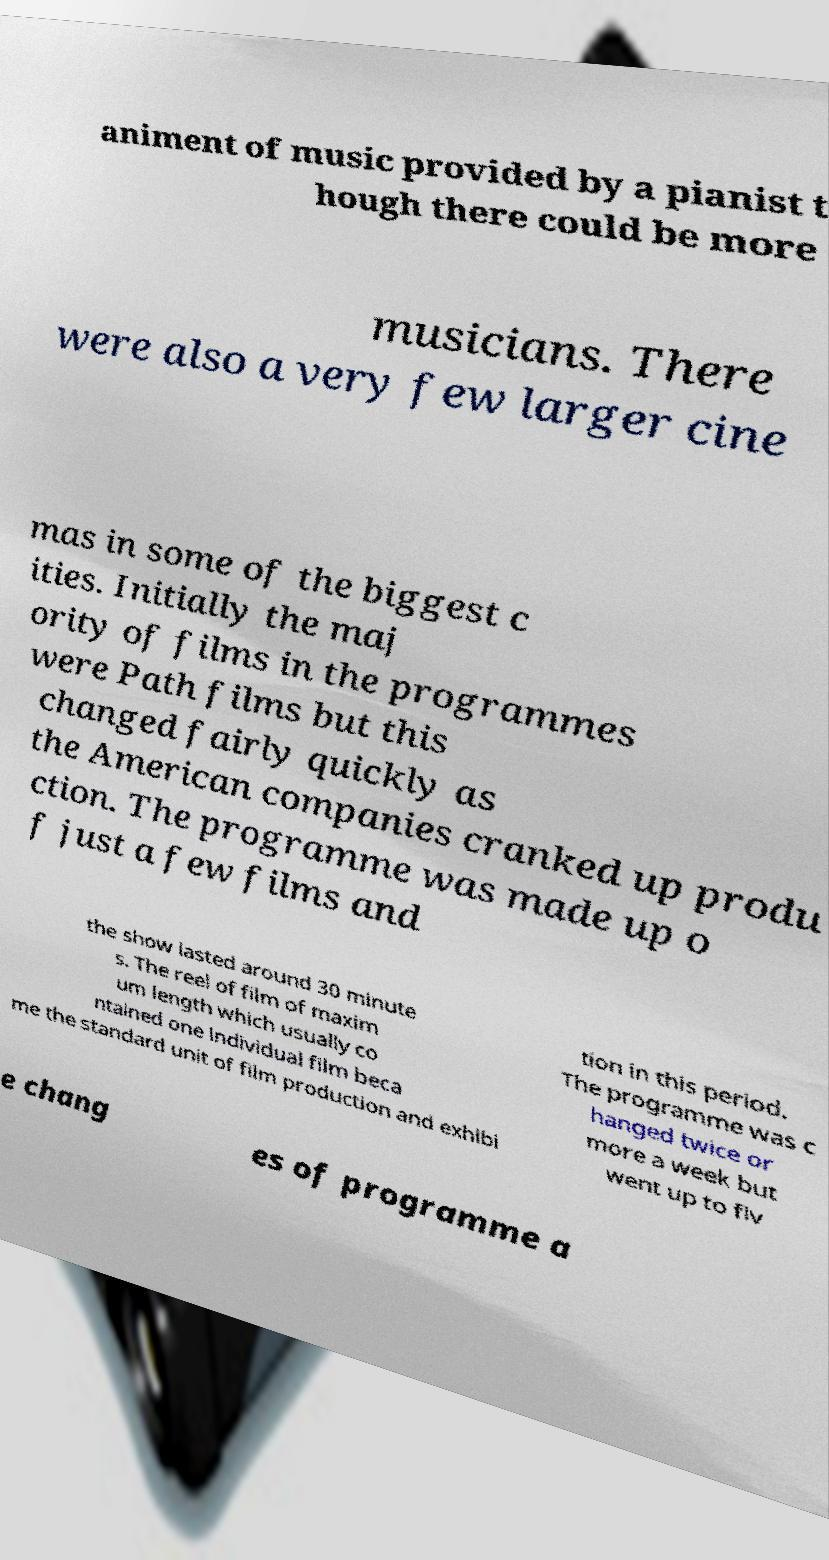I need the written content from this picture converted into text. Can you do that? animent of music provided by a pianist t hough there could be more musicians. There were also a very few larger cine mas in some of the biggest c ities. Initially the maj ority of films in the programmes were Path films but this changed fairly quickly as the American companies cranked up produ ction. The programme was made up o f just a few films and the show lasted around 30 minute s. The reel of film of maxim um length which usually co ntained one individual film beca me the standard unit of film production and exhibi tion in this period. The programme was c hanged twice or more a week but went up to fiv e chang es of programme a 